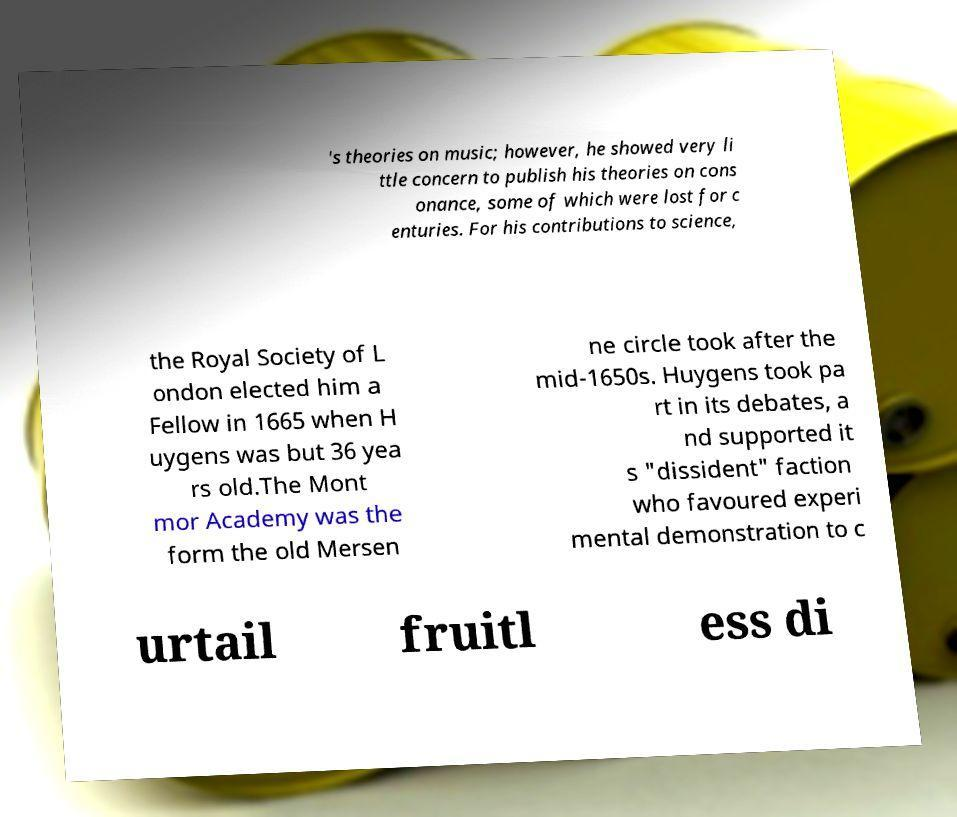What messages or text are displayed in this image? I need them in a readable, typed format. 's theories on music; however, he showed very li ttle concern to publish his theories on cons onance, some of which were lost for c enturies. For his contributions to science, the Royal Society of L ondon elected him a Fellow in 1665 when H uygens was but 36 yea rs old.The Mont mor Academy was the form the old Mersen ne circle took after the mid-1650s. Huygens took pa rt in its debates, a nd supported it s "dissident" faction who favoured experi mental demonstration to c urtail fruitl ess di 